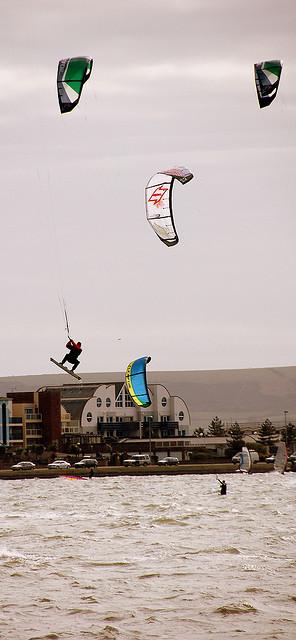Is it going to rain?
Concise answer only. No. Is this a dangerous sport?
Quick response, please. Yes. How is the man lifted off of the water?
Short answer required. Kite. 